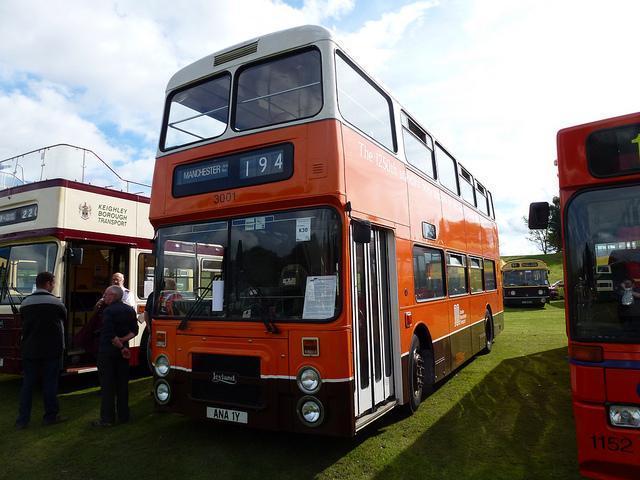How many busses are there?
Give a very brief answer. 3. How many buses can be seen?
Give a very brief answer. 3. How many people can you see?
Give a very brief answer. 2. 